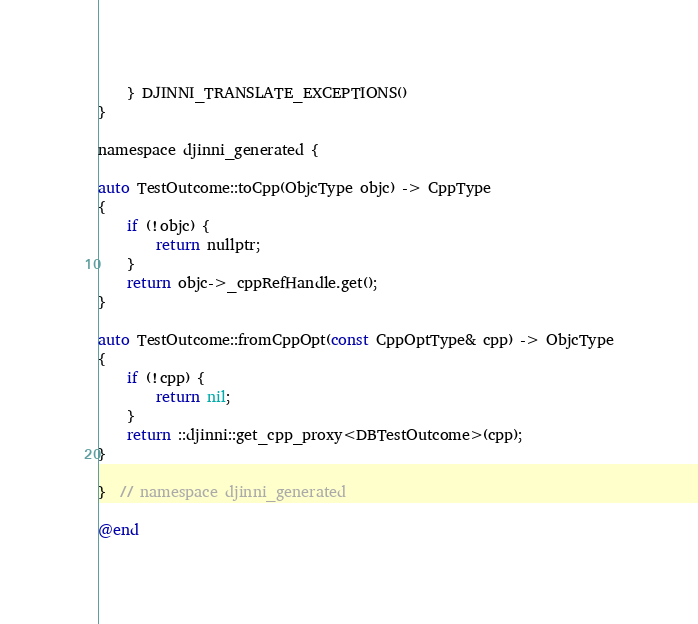Convert code to text. <code><loc_0><loc_0><loc_500><loc_500><_ObjectiveC_>    } DJINNI_TRANSLATE_EXCEPTIONS()
}

namespace djinni_generated {

auto TestOutcome::toCpp(ObjcType objc) -> CppType
{
    if (!objc) {
        return nullptr;
    }
    return objc->_cppRefHandle.get();
}

auto TestOutcome::fromCppOpt(const CppOptType& cpp) -> ObjcType
{
    if (!cpp) {
        return nil;
    }
    return ::djinni::get_cpp_proxy<DBTestOutcome>(cpp);
}

}  // namespace djinni_generated

@end
</code> 